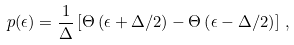Convert formula to latex. <formula><loc_0><loc_0><loc_500><loc_500>p ( \epsilon ) = \frac { 1 } { \Delta } \left [ \Theta \left ( \epsilon + \Delta / 2 \right ) - \Theta \left ( \epsilon - \Delta / 2 \right ) \right ] \, ,</formula> 